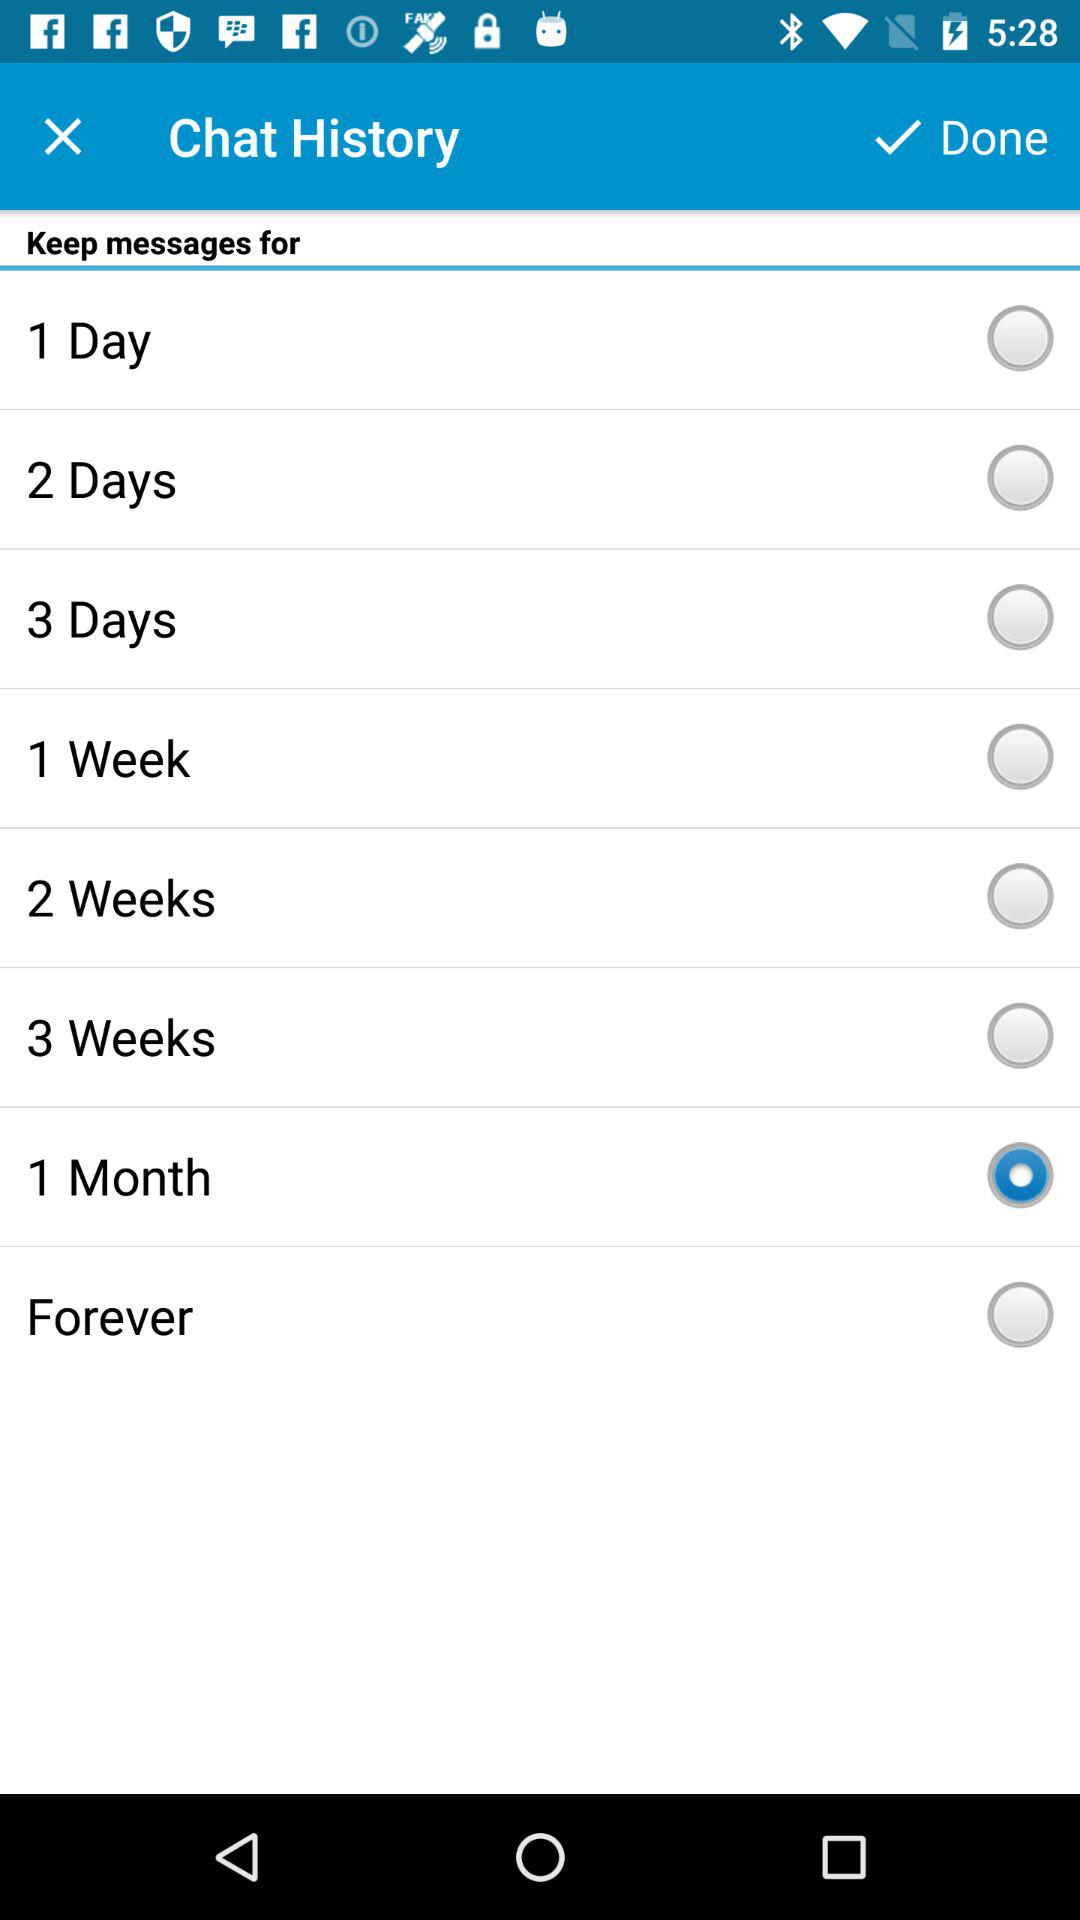Which option was selected? The selected option was "1 Month". 